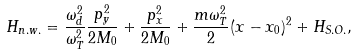<formula> <loc_0><loc_0><loc_500><loc_500>H _ { n . w . } = \frac { \omega _ { d } ^ { 2 } } { \omega _ { T } ^ { 2 } } \frac { p _ { y } ^ { 2 } } { 2 M _ { 0 } } + \frac { p _ { x } ^ { 2 } } { 2 M _ { 0 } } + \frac { m \omega _ { T } ^ { 2 } } { 2 } ( x - x _ { 0 } ) ^ { 2 } + H _ { S . O . } ,</formula> 